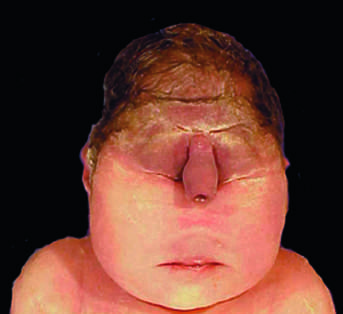what are fused or ill-formed?
Answer the question using a single word or phrase. The midface structures 